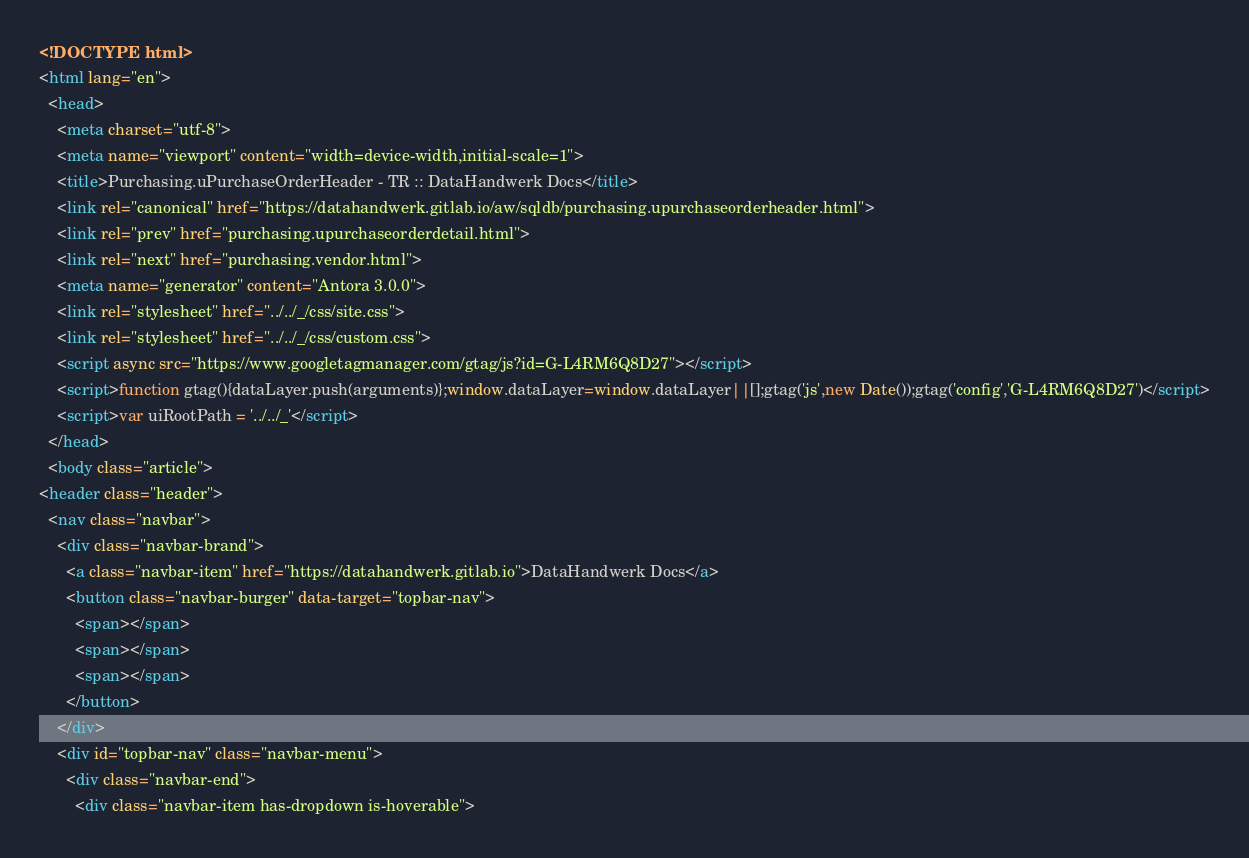<code> <loc_0><loc_0><loc_500><loc_500><_HTML_><!DOCTYPE html>
<html lang="en">
  <head>
    <meta charset="utf-8">
    <meta name="viewport" content="width=device-width,initial-scale=1">
    <title>Purchasing.uPurchaseOrderHeader - TR :: DataHandwerk Docs</title>
    <link rel="canonical" href="https://datahandwerk.gitlab.io/aw/sqldb/purchasing.upurchaseorderheader.html">
    <link rel="prev" href="purchasing.upurchaseorderdetail.html">
    <link rel="next" href="purchasing.vendor.html">
    <meta name="generator" content="Antora 3.0.0">
    <link rel="stylesheet" href="../../_/css/site.css">
    <link rel="stylesheet" href="../../_/css/custom.css">
    <script async src="https://www.googletagmanager.com/gtag/js?id=G-L4RM6Q8D27"></script>
    <script>function gtag(){dataLayer.push(arguments)};window.dataLayer=window.dataLayer||[];gtag('js',new Date());gtag('config','G-L4RM6Q8D27')</script>
    <script>var uiRootPath = '../../_'</script>
  </head>
  <body class="article">
<header class="header">
  <nav class="navbar">
    <div class="navbar-brand">
      <a class="navbar-item" href="https://datahandwerk.gitlab.io">DataHandwerk Docs</a>
      <button class="navbar-burger" data-target="topbar-nav">
        <span></span>
        <span></span>
        <span></span>
      </button>
    </div>
    <div id="topbar-nav" class="navbar-menu">
      <div class="navbar-end">
        <div class="navbar-item has-dropdown is-hoverable"></code> 